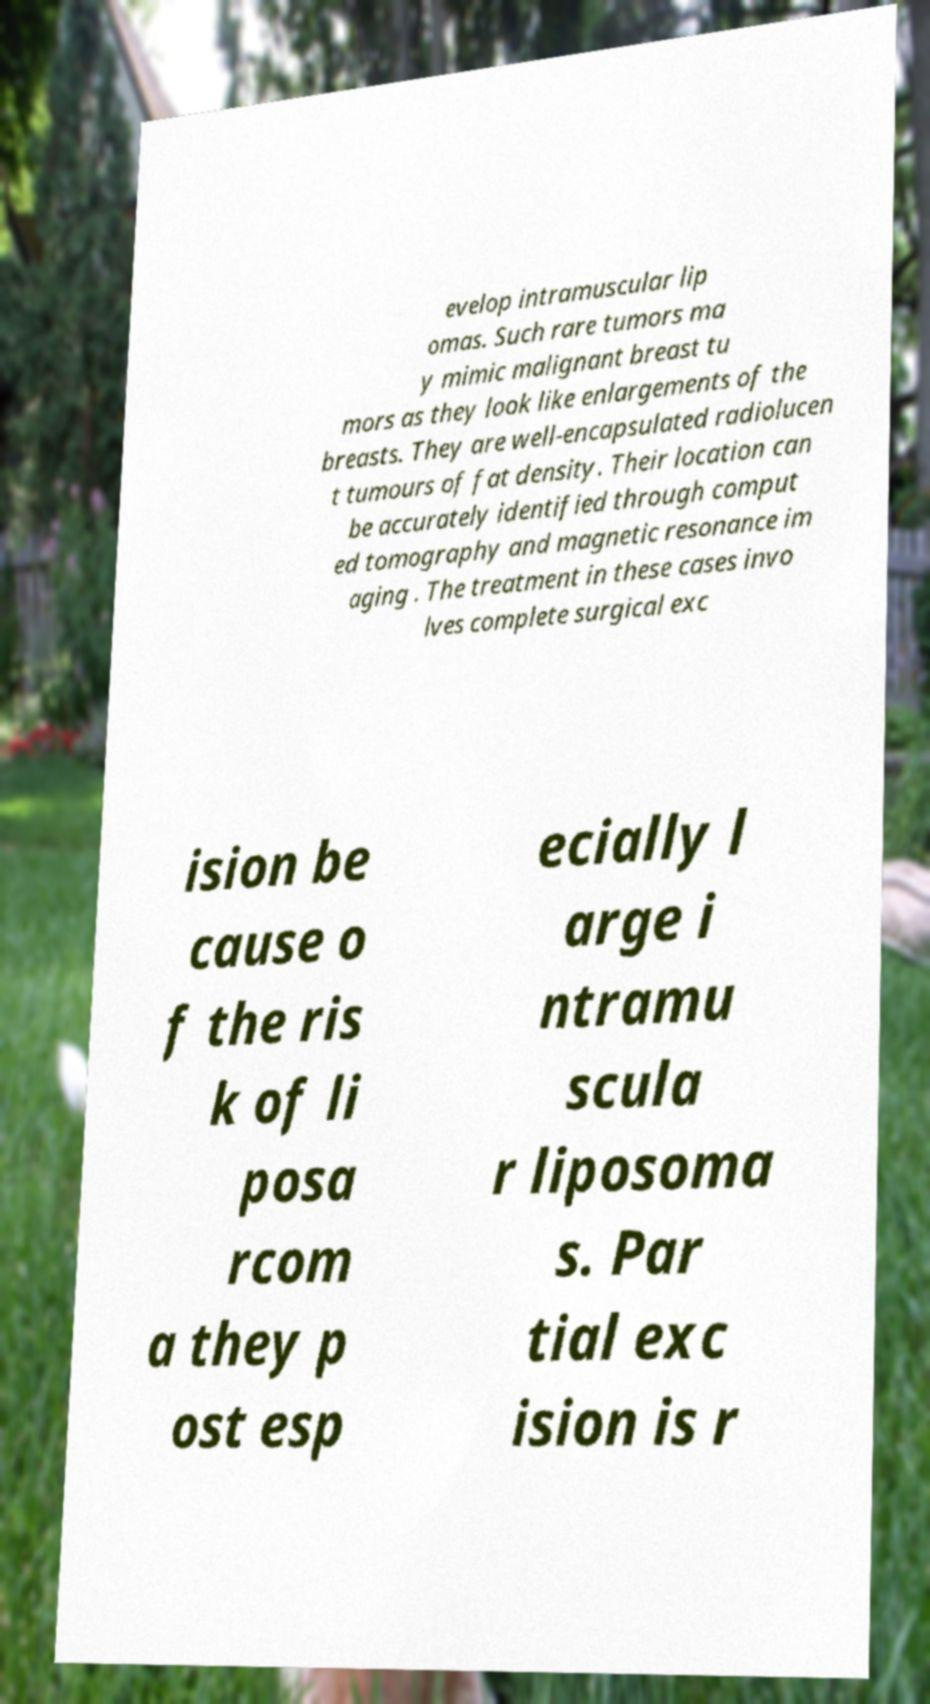There's text embedded in this image that I need extracted. Can you transcribe it verbatim? evelop intramuscular lip omas. Such rare tumors ma y mimic malignant breast tu mors as they look like enlargements of the breasts. They are well-encapsulated radiolucen t tumours of fat density. Their location can be accurately identified through comput ed tomography and magnetic resonance im aging . The treatment in these cases invo lves complete surgical exc ision be cause o f the ris k of li posa rcom a they p ost esp ecially l arge i ntramu scula r liposoma s. Par tial exc ision is r 